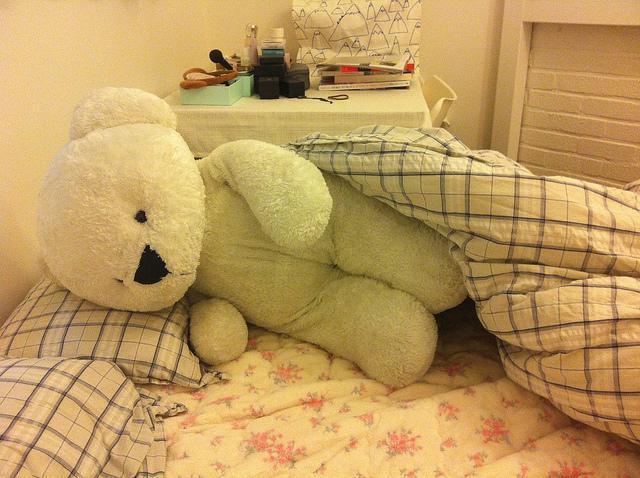How many stuffed animals are there?
Give a very brief answer. 1. How many bears are in this picture?
Give a very brief answer. 0. 